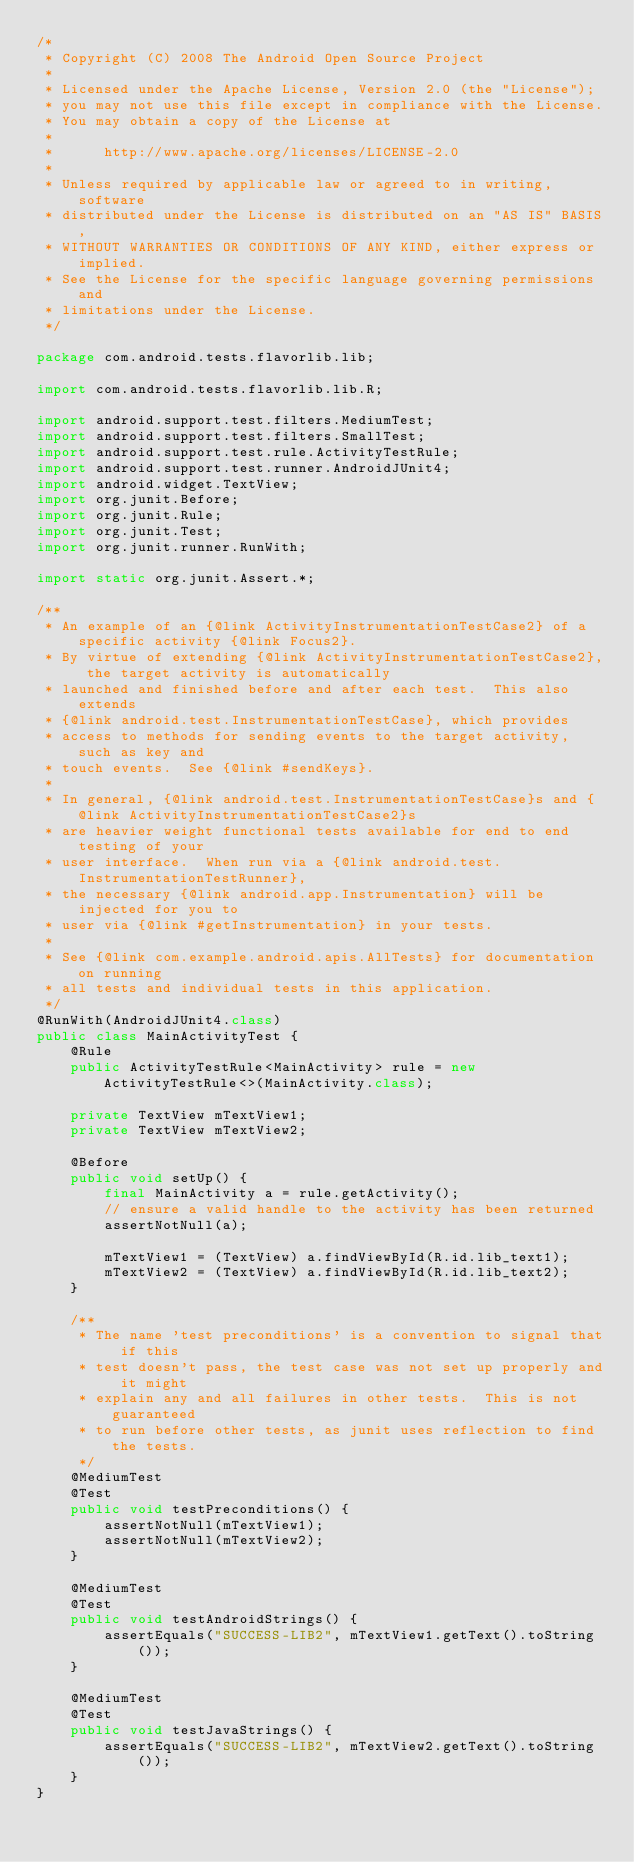<code> <loc_0><loc_0><loc_500><loc_500><_Java_>/*
 * Copyright (C) 2008 The Android Open Source Project
 *
 * Licensed under the Apache License, Version 2.0 (the "License");
 * you may not use this file except in compliance with the License.
 * You may obtain a copy of the License at
 *
 *      http://www.apache.org/licenses/LICENSE-2.0
 *
 * Unless required by applicable law or agreed to in writing, software
 * distributed under the License is distributed on an "AS IS" BASIS,
 * WITHOUT WARRANTIES OR CONDITIONS OF ANY KIND, either express or implied.
 * See the License for the specific language governing permissions and
 * limitations under the License.
 */

package com.android.tests.flavorlib.lib;

import com.android.tests.flavorlib.lib.R;

import android.support.test.filters.MediumTest;
import android.support.test.filters.SmallTest;
import android.support.test.rule.ActivityTestRule;
import android.support.test.runner.AndroidJUnit4;
import android.widget.TextView;
import org.junit.Before;
import org.junit.Rule;
import org.junit.Test;
import org.junit.runner.RunWith;

import static org.junit.Assert.*;

/**
 * An example of an {@link ActivityInstrumentationTestCase2} of a specific activity {@link Focus2}.
 * By virtue of extending {@link ActivityInstrumentationTestCase2}, the target activity is automatically
 * launched and finished before and after each test.  This also extends
 * {@link android.test.InstrumentationTestCase}, which provides
 * access to methods for sending events to the target activity, such as key and
 * touch events.  See {@link #sendKeys}.
 *
 * In general, {@link android.test.InstrumentationTestCase}s and {@link ActivityInstrumentationTestCase2}s
 * are heavier weight functional tests available for end to end testing of your
 * user interface.  When run via a {@link android.test.InstrumentationTestRunner},
 * the necessary {@link android.app.Instrumentation} will be injected for you to
 * user via {@link #getInstrumentation} in your tests.
 *
 * See {@link com.example.android.apis.AllTests} for documentation on running
 * all tests and individual tests in this application.
 */
@RunWith(AndroidJUnit4.class)
public class MainActivityTest {
    @Rule
    public ActivityTestRule<MainActivity> rule = new ActivityTestRule<>(MainActivity.class);

    private TextView mTextView1;
    private TextView mTextView2;

    @Before
    public void setUp() {
        final MainActivity a = rule.getActivity();
        // ensure a valid handle to the activity has been returned
        assertNotNull(a);

        mTextView1 = (TextView) a.findViewById(R.id.lib_text1);
        mTextView2 = (TextView) a.findViewById(R.id.lib_text2);
    }

    /**
     * The name 'test preconditions' is a convention to signal that if this
     * test doesn't pass, the test case was not set up properly and it might
     * explain any and all failures in other tests.  This is not guaranteed
     * to run before other tests, as junit uses reflection to find the tests.
     */
    @MediumTest
    @Test
    public void testPreconditions() {
        assertNotNull(mTextView1);
        assertNotNull(mTextView2);
    }

    @MediumTest
    @Test
    public void testAndroidStrings() {
        assertEquals("SUCCESS-LIB2", mTextView1.getText().toString());
    }

    @MediumTest
    @Test
    public void testJavaStrings() {
        assertEquals("SUCCESS-LIB2", mTextView2.getText().toString());
    }
}
</code> 